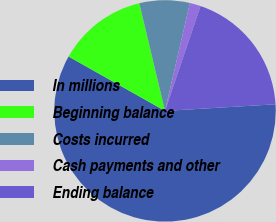Convert chart to OTSL. <chart><loc_0><loc_0><loc_500><loc_500><pie_chart><fcel>In millions<fcel>Beginning balance<fcel>Costs incurred<fcel>Cash payments and other<fcel>Ending balance<nl><fcel>59.13%<fcel>13.1%<fcel>7.34%<fcel>1.59%<fcel>18.85%<nl></chart> 